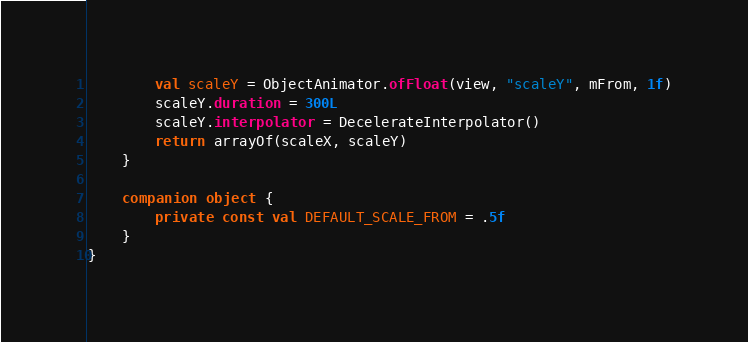Convert code to text. <code><loc_0><loc_0><loc_500><loc_500><_Kotlin_>
        val scaleY = ObjectAnimator.ofFloat(view, "scaleY", mFrom, 1f)
        scaleY.duration = 300L
        scaleY.interpolator = DecelerateInterpolator()
        return arrayOf(scaleX, scaleY)
    }

    companion object {
        private const val DEFAULT_SCALE_FROM = .5f
    }
}</code> 